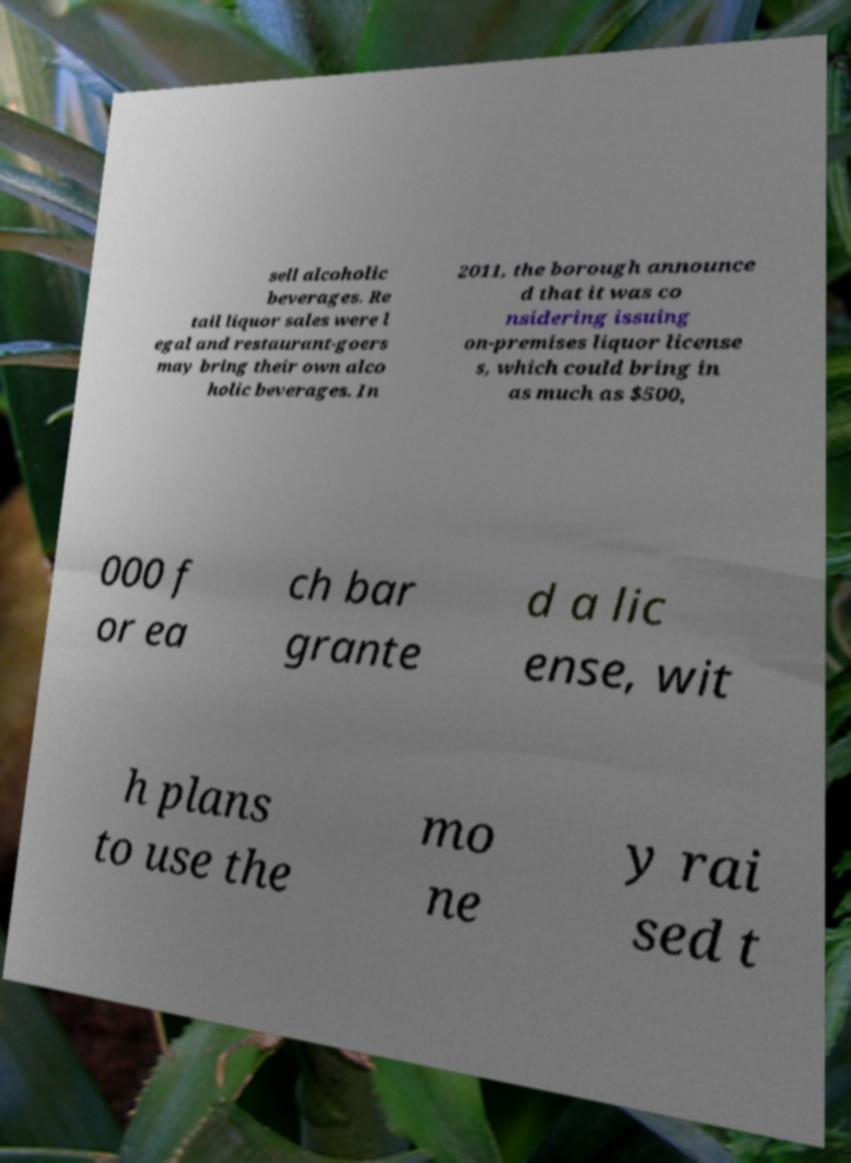Please identify and transcribe the text found in this image. sell alcoholic beverages. Re tail liquor sales were l egal and restaurant-goers may bring their own alco holic beverages. In 2011, the borough announce d that it was co nsidering issuing on-premises liquor license s, which could bring in as much as $500, 000 f or ea ch bar grante d a lic ense, wit h plans to use the mo ne y rai sed t 